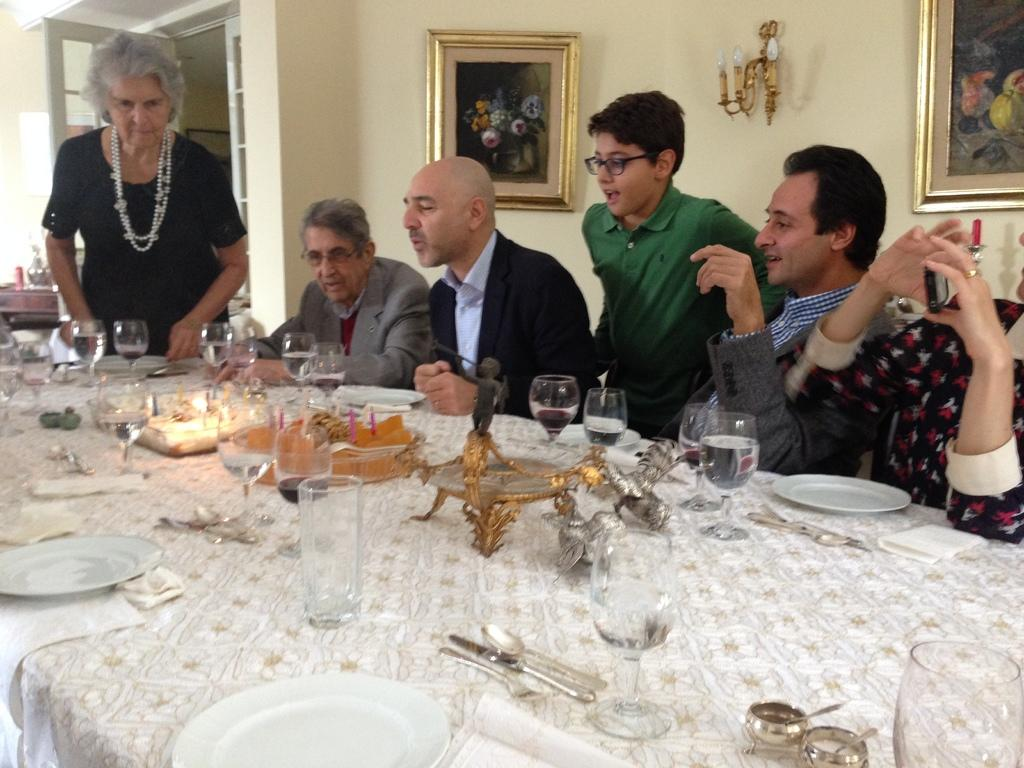Who or what can be seen in the image? There are people in the image. What are the people doing or standing near? The people are in front of a table. What items are on the table? There are glasses, food, spoons, and a plate on the table. Are there any decorative elements in the background? Yes, there are photo frames in the background. What is visible behind the photo frames? There is a wall visible in the background. What type of quill is being used by the person in the image? There is no quill present in the image; it features people in front of a table with glasses, food, spoons, and a plate. Can you see a guitar being played by anyone in the image? There is no guitar present in the image; it features people in front of a table with glasses, food, spoons, and a plate. 